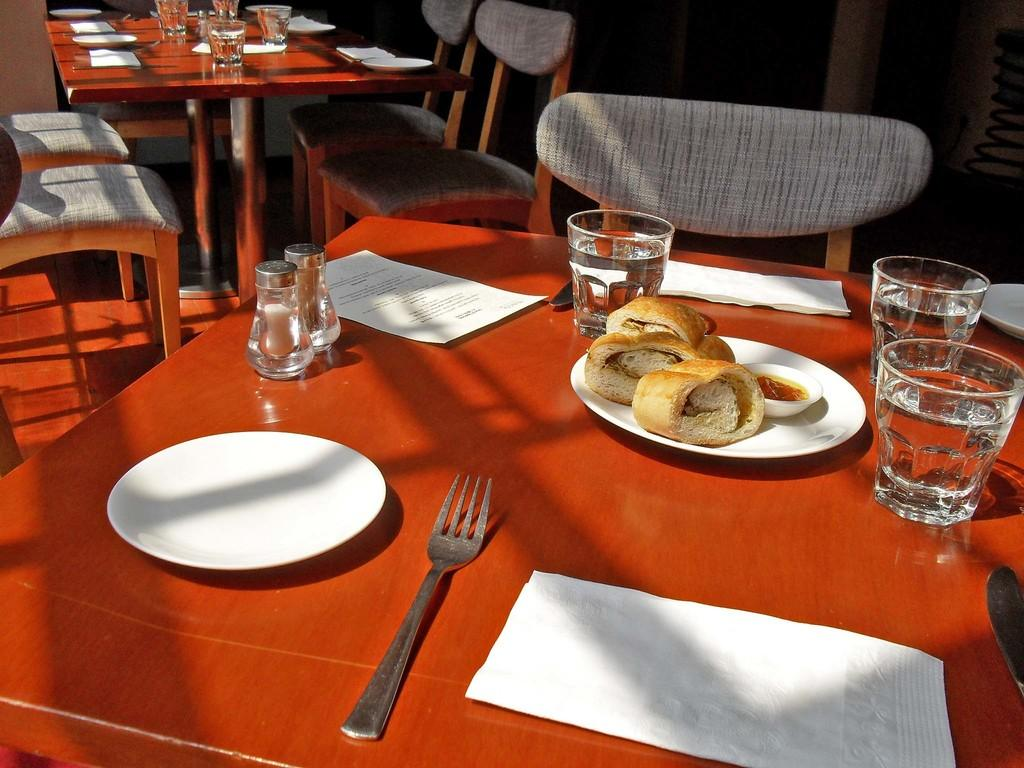What piece of furniture is present in the image? There is a table in the image. What is placed on the table? There is a plate, a fork, a napkin, a bun, a bowl, curry, and a glass on the table. What is in the bowl? There is curry in the bowl. What is in the glass? The glass is filled with water. How many brothers are sitting at the table in the image? There is no information about any brothers in the image; it only shows a table with various items on it. 